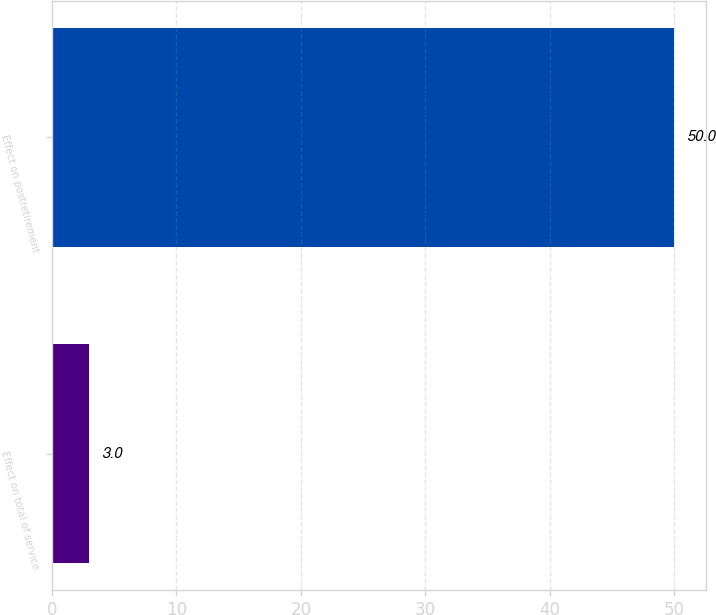Convert chart to OTSL. <chart><loc_0><loc_0><loc_500><loc_500><bar_chart><fcel>Effect on total of service<fcel>Effect on postretirement<nl><fcel>3<fcel>50<nl></chart> 